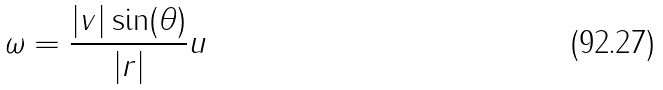Convert formula to latex. <formula><loc_0><loc_0><loc_500><loc_500>\omega = \frac { | v | \sin ( \theta ) } { | r | } u</formula> 